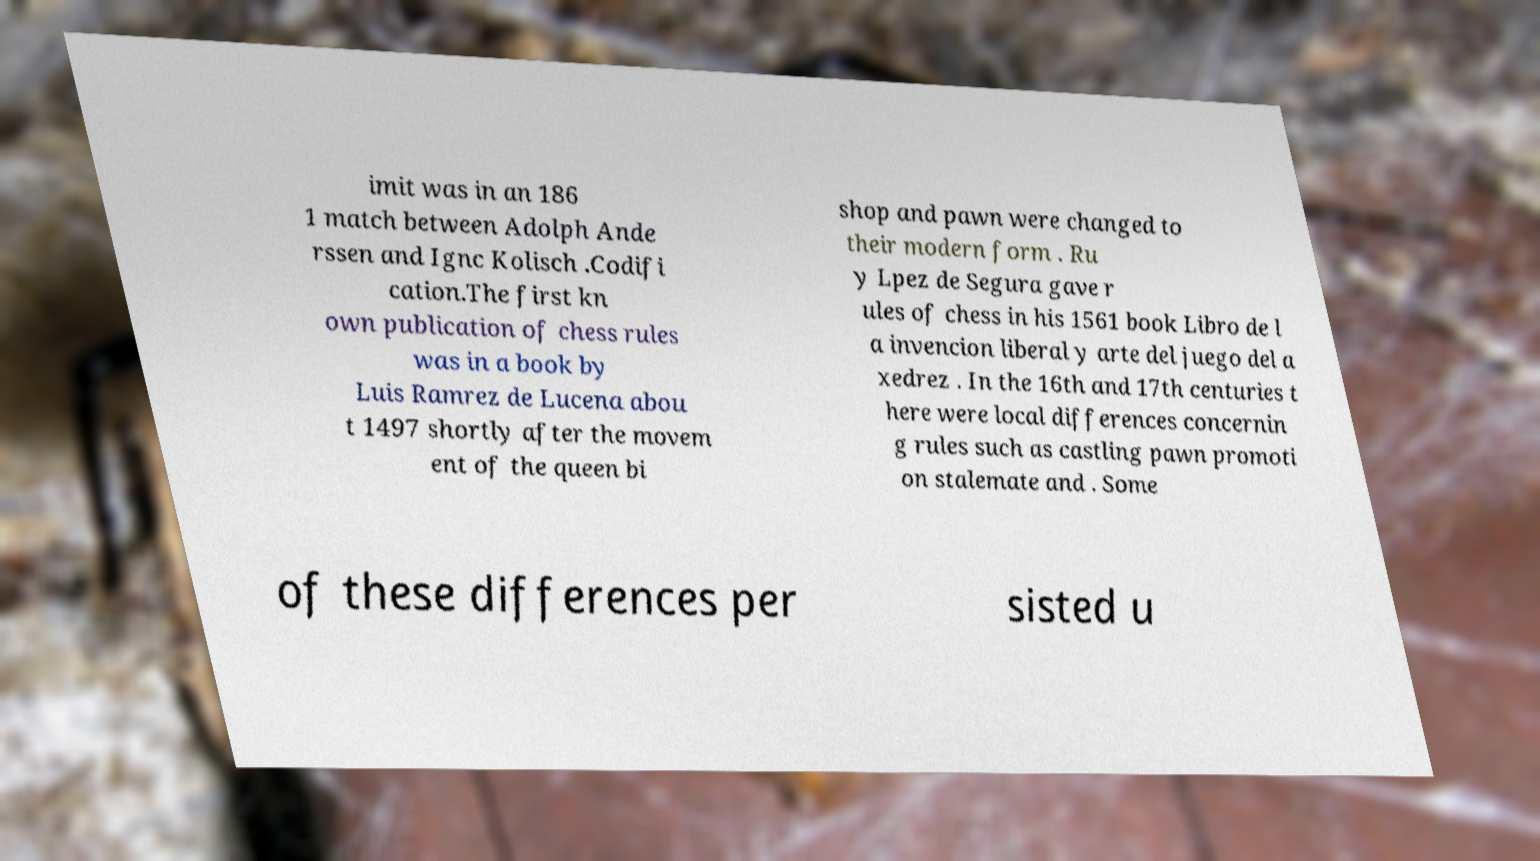For documentation purposes, I need the text within this image transcribed. Could you provide that? imit was in an 186 1 match between Adolph Ande rssen and Ignc Kolisch .Codifi cation.The first kn own publication of chess rules was in a book by Luis Ramrez de Lucena abou t 1497 shortly after the movem ent of the queen bi shop and pawn were changed to their modern form . Ru y Lpez de Segura gave r ules of chess in his 1561 book Libro de l a invencion liberal y arte del juego del a xedrez . In the 16th and 17th centuries t here were local differences concernin g rules such as castling pawn promoti on stalemate and . Some of these differences per sisted u 